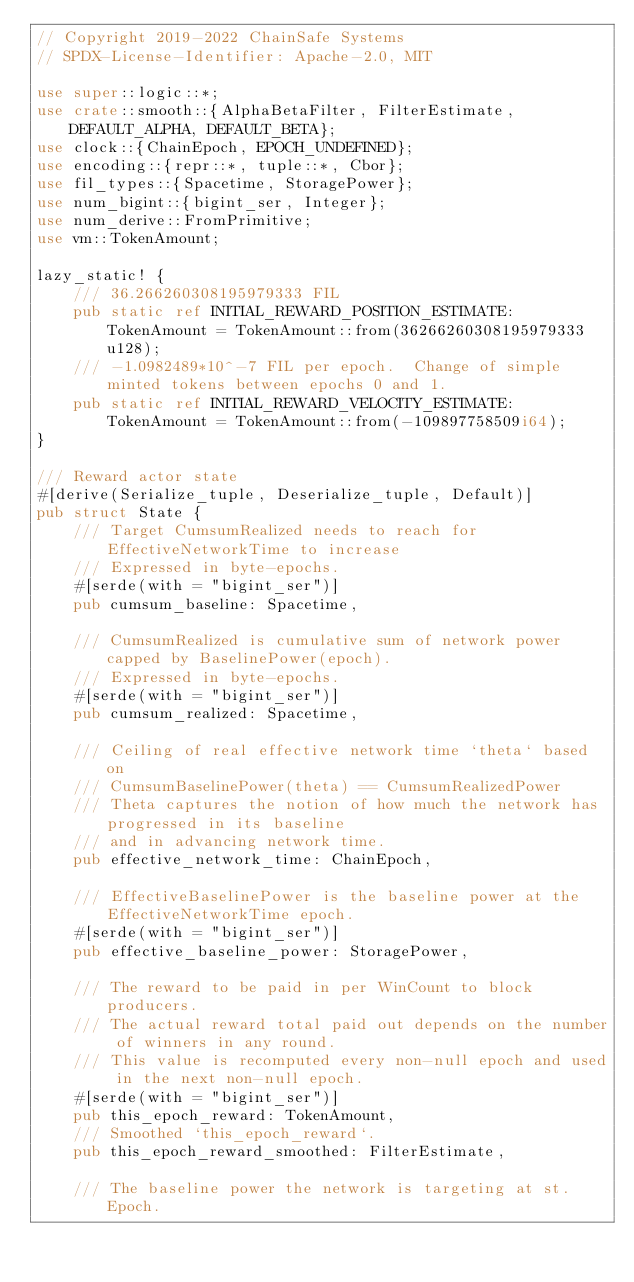Convert code to text. <code><loc_0><loc_0><loc_500><loc_500><_Rust_>// Copyright 2019-2022 ChainSafe Systems
// SPDX-License-Identifier: Apache-2.0, MIT

use super::logic::*;
use crate::smooth::{AlphaBetaFilter, FilterEstimate, DEFAULT_ALPHA, DEFAULT_BETA};
use clock::{ChainEpoch, EPOCH_UNDEFINED};
use encoding::{repr::*, tuple::*, Cbor};
use fil_types::{Spacetime, StoragePower};
use num_bigint::{bigint_ser, Integer};
use num_derive::FromPrimitive;
use vm::TokenAmount;

lazy_static! {
    /// 36.266260308195979333 FIL
    pub static ref INITIAL_REWARD_POSITION_ESTIMATE: TokenAmount = TokenAmount::from(36266260308195979333u128);
    /// -1.0982489*10^-7 FIL per epoch.  Change of simple minted tokens between epochs 0 and 1.
    pub static ref INITIAL_REWARD_VELOCITY_ESTIMATE: TokenAmount = TokenAmount::from(-109897758509i64);
}

/// Reward actor state
#[derive(Serialize_tuple, Deserialize_tuple, Default)]
pub struct State {
    /// Target CumsumRealized needs to reach for EffectiveNetworkTime to increase
    /// Expressed in byte-epochs.
    #[serde(with = "bigint_ser")]
    pub cumsum_baseline: Spacetime,

    /// CumsumRealized is cumulative sum of network power capped by BaselinePower(epoch).
    /// Expressed in byte-epochs.
    #[serde(with = "bigint_ser")]
    pub cumsum_realized: Spacetime,

    /// Ceiling of real effective network time `theta` based on
    /// CumsumBaselinePower(theta) == CumsumRealizedPower
    /// Theta captures the notion of how much the network has progressed in its baseline
    /// and in advancing network time.
    pub effective_network_time: ChainEpoch,

    /// EffectiveBaselinePower is the baseline power at the EffectiveNetworkTime epoch.
    #[serde(with = "bigint_ser")]
    pub effective_baseline_power: StoragePower,

    /// The reward to be paid in per WinCount to block producers.
    /// The actual reward total paid out depends on the number of winners in any round.
    /// This value is recomputed every non-null epoch and used in the next non-null epoch.
    #[serde(with = "bigint_ser")]
    pub this_epoch_reward: TokenAmount,
    /// Smoothed `this_epoch_reward`.
    pub this_epoch_reward_smoothed: FilterEstimate,

    /// The baseline power the network is targeting at st.Epoch.</code> 